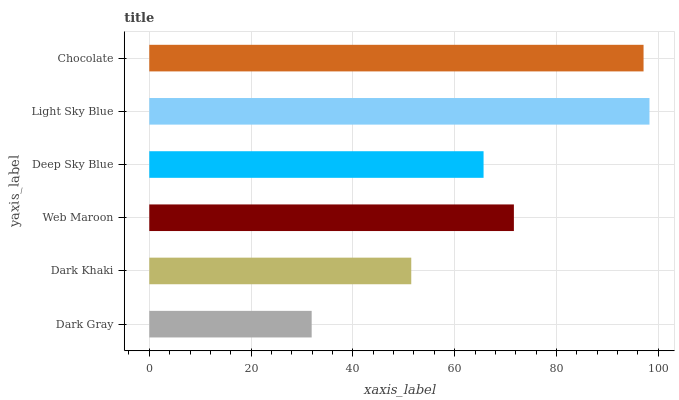Is Dark Gray the minimum?
Answer yes or no. Yes. Is Light Sky Blue the maximum?
Answer yes or no. Yes. Is Dark Khaki the minimum?
Answer yes or no. No. Is Dark Khaki the maximum?
Answer yes or no. No. Is Dark Khaki greater than Dark Gray?
Answer yes or no. Yes. Is Dark Gray less than Dark Khaki?
Answer yes or no. Yes. Is Dark Gray greater than Dark Khaki?
Answer yes or no. No. Is Dark Khaki less than Dark Gray?
Answer yes or no. No. Is Web Maroon the high median?
Answer yes or no. Yes. Is Deep Sky Blue the low median?
Answer yes or no. Yes. Is Dark Gray the high median?
Answer yes or no. No. Is Dark Gray the low median?
Answer yes or no. No. 